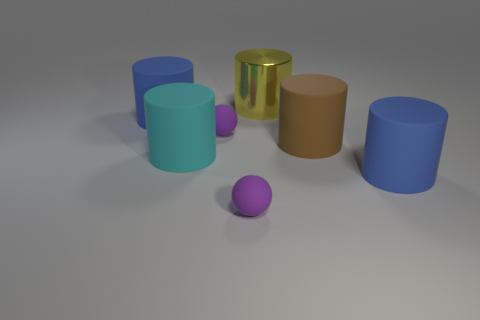What number of blue rubber cylinders have the same size as the yellow cylinder?
Offer a terse response. 2. How many objects are in front of the blue thing on the right side of the cyan object?
Keep it short and to the point. 1. What is the size of the rubber object that is both to the left of the yellow metallic thing and in front of the big cyan matte cylinder?
Your response must be concise. Small. Are there more brown rubber objects than large blue metallic balls?
Make the answer very short. Yes. Is there a tiny ball of the same color as the big shiny object?
Offer a very short reply. No. Is the size of the purple matte ball that is behind the brown cylinder the same as the large yellow cylinder?
Provide a succinct answer. No. Is the number of tiny spheres less than the number of cyan matte objects?
Provide a succinct answer. No. Are there any other big things made of the same material as the cyan thing?
Provide a short and direct response. Yes. What is the shape of the big rubber thing that is to the right of the big brown rubber cylinder?
Keep it short and to the point. Cylinder. There is a large matte cylinder right of the brown matte cylinder; is it the same color as the metallic cylinder?
Provide a short and direct response. No. 